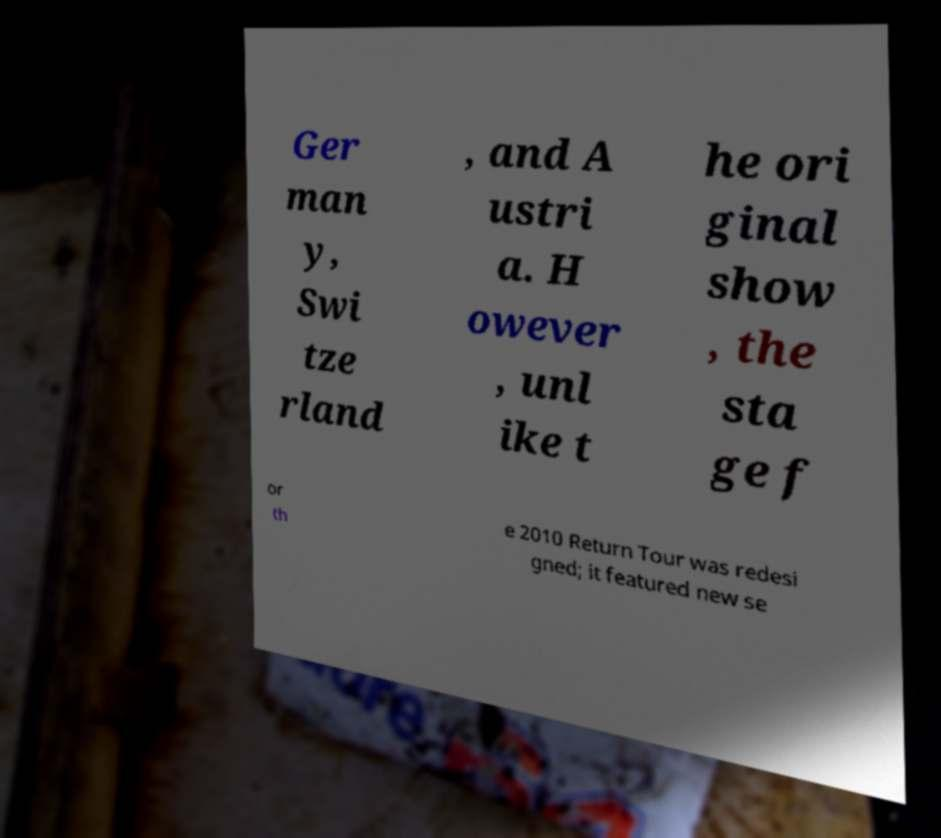I need the written content from this picture converted into text. Can you do that? Ger man y, Swi tze rland , and A ustri a. H owever , unl ike t he ori ginal show , the sta ge f or th e 2010 Return Tour was redesi gned; it featured new se 